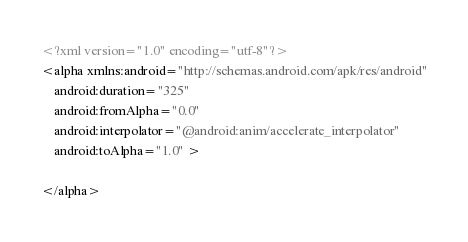Convert code to text. <code><loc_0><loc_0><loc_500><loc_500><_XML_><?xml version="1.0" encoding="utf-8"?>
<alpha xmlns:android="http://schemas.android.com/apk/res/android"
    android:duration="325"
    android:fromAlpha="0.0"
    android:interpolator="@android:anim/accelerate_interpolator"
    android:toAlpha="1.0" >

</alpha></code> 